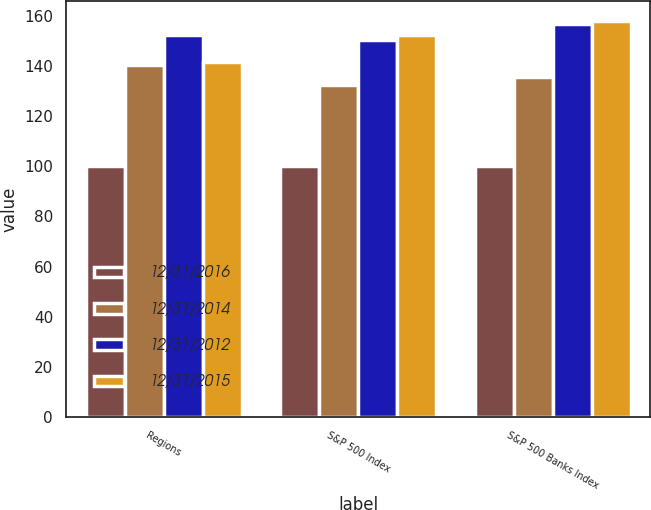<chart> <loc_0><loc_0><loc_500><loc_500><stacked_bar_chart><ecel><fcel>Regions<fcel>S&P 500 Index<fcel>S&P 500 Banks Index<nl><fcel>12/31/2016<fcel>100<fcel>100<fcel>100<nl><fcel>12/31/2014<fcel>140.22<fcel>132.37<fcel>135.72<nl><fcel>12/31/2012<fcel>152.32<fcel>150.48<fcel>156.78<nl><fcel>12/31/2015<fcel>141.78<fcel>152.55<fcel>158.1<nl></chart> 